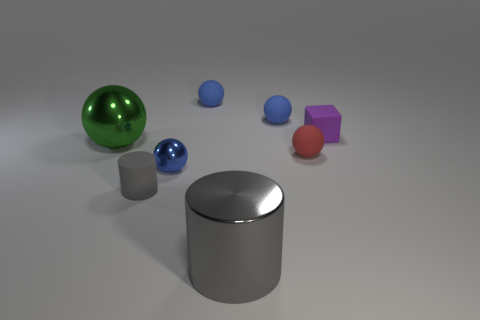Do the gray rubber object and the gray metal thing have the same shape?
Your answer should be very brief. Yes. What number of things are either big gray shiny objects or rubber spheres that are behind the red rubber thing?
Your response must be concise. 3. How many balls are there?
Offer a very short reply. 5. Are there any blue metal things that have the same size as the purple matte thing?
Provide a succinct answer. Yes. Is the number of small purple cubes that are right of the small red ball less than the number of large red rubber balls?
Provide a succinct answer. No. Is the size of the gray metallic cylinder the same as the rubber block?
Your answer should be very brief. No. What is the size of the gray thing that is the same material as the block?
Give a very brief answer. Small. What number of large metal spheres have the same color as the small cylinder?
Give a very brief answer. 0. Is the number of gray cylinders to the left of the big gray metallic object less than the number of tiny blocks that are to the right of the small metal object?
Your answer should be compact. No. There is a blue object that is in front of the purple cube; is it the same shape as the tiny red rubber thing?
Provide a short and direct response. Yes. 